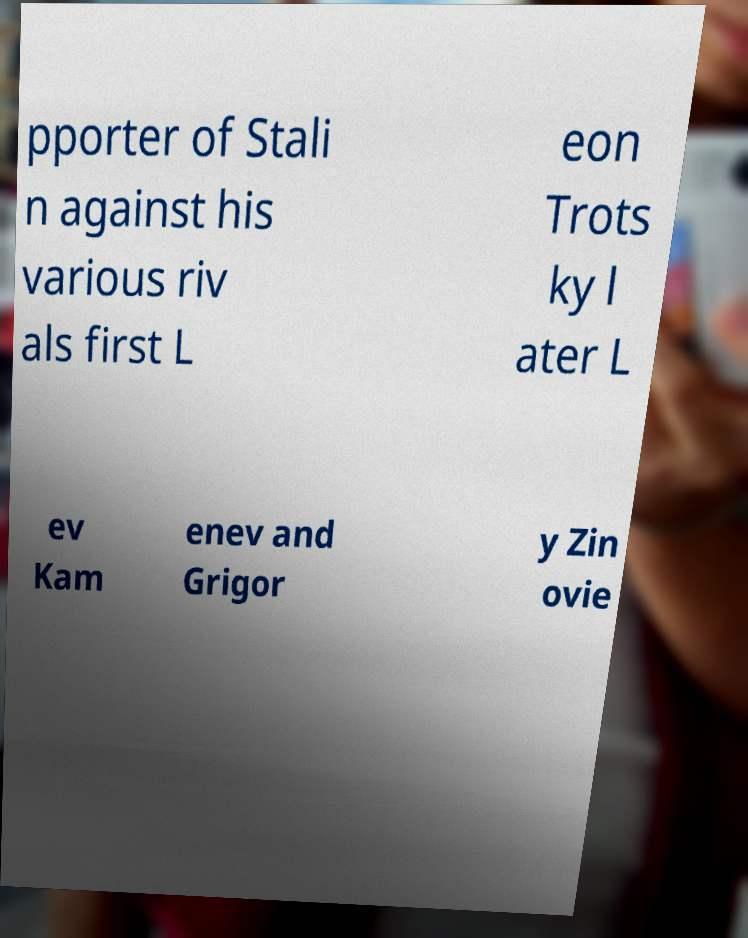Can you read and provide the text displayed in the image?This photo seems to have some interesting text. Can you extract and type it out for me? pporter of Stali n against his various riv als first L eon Trots ky l ater L ev Kam enev and Grigor y Zin ovie 